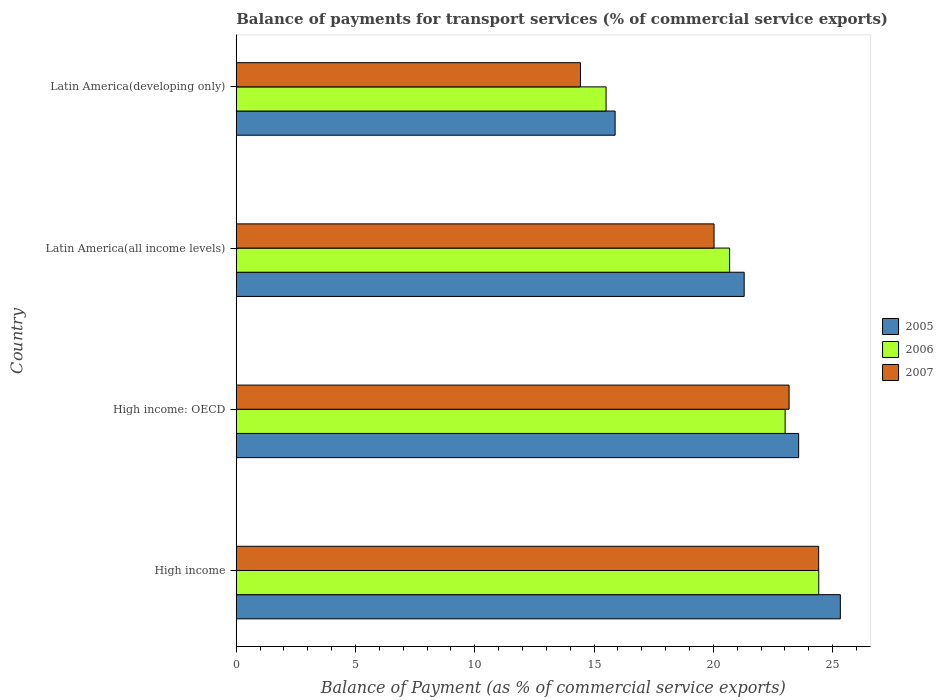How many groups of bars are there?
Provide a succinct answer. 4. Are the number of bars per tick equal to the number of legend labels?
Offer a very short reply. Yes. How many bars are there on the 3rd tick from the bottom?
Provide a succinct answer. 3. What is the label of the 1st group of bars from the top?
Ensure brevity in your answer.  Latin America(developing only). What is the balance of payments for transport services in 2005 in Latin America(developing only)?
Make the answer very short. 15.88. Across all countries, what is the maximum balance of payments for transport services in 2007?
Ensure brevity in your answer.  24.42. Across all countries, what is the minimum balance of payments for transport services in 2007?
Provide a short and direct response. 14.43. In which country was the balance of payments for transport services in 2007 minimum?
Your response must be concise. Latin America(developing only). What is the total balance of payments for transport services in 2007 in the graph?
Your response must be concise. 82.06. What is the difference between the balance of payments for transport services in 2006 in High income: OECD and that in Latin America(all income levels)?
Offer a terse response. 2.33. What is the difference between the balance of payments for transport services in 2005 in High income: OECD and the balance of payments for transport services in 2006 in Latin America(developing only)?
Offer a very short reply. 8.07. What is the average balance of payments for transport services in 2007 per country?
Make the answer very short. 20.51. What is the difference between the balance of payments for transport services in 2006 and balance of payments for transport services in 2005 in High income: OECD?
Make the answer very short. -0.57. In how many countries, is the balance of payments for transport services in 2005 greater than 4 %?
Keep it short and to the point. 4. What is the ratio of the balance of payments for transport services in 2007 in Latin America(all income levels) to that in Latin America(developing only)?
Offer a terse response. 1.39. What is the difference between the highest and the second highest balance of payments for transport services in 2006?
Provide a short and direct response. 1.41. What is the difference between the highest and the lowest balance of payments for transport services in 2005?
Give a very brief answer. 9.44. What does the 3rd bar from the top in Latin America(developing only) represents?
Your answer should be compact. 2005. Are all the bars in the graph horizontal?
Give a very brief answer. Yes. Are the values on the major ticks of X-axis written in scientific E-notation?
Make the answer very short. No. Does the graph contain any zero values?
Make the answer very short. No. Where does the legend appear in the graph?
Give a very brief answer. Center right. How many legend labels are there?
Ensure brevity in your answer.  3. What is the title of the graph?
Provide a short and direct response. Balance of payments for transport services (% of commercial service exports). What is the label or title of the X-axis?
Provide a succinct answer. Balance of Payment (as % of commercial service exports). What is the label or title of the Y-axis?
Give a very brief answer. Country. What is the Balance of Payment (as % of commercial service exports) in 2005 in High income?
Your response must be concise. 25.33. What is the Balance of Payment (as % of commercial service exports) of 2006 in High income?
Provide a succinct answer. 24.42. What is the Balance of Payment (as % of commercial service exports) of 2007 in High income?
Provide a succinct answer. 24.42. What is the Balance of Payment (as % of commercial service exports) in 2005 in High income: OECD?
Offer a terse response. 23.58. What is the Balance of Payment (as % of commercial service exports) in 2006 in High income: OECD?
Offer a very short reply. 23.01. What is the Balance of Payment (as % of commercial service exports) in 2007 in High income: OECD?
Keep it short and to the point. 23.18. What is the Balance of Payment (as % of commercial service exports) in 2005 in Latin America(all income levels)?
Keep it short and to the point. 21.29. What is the Balance of Payment (as % of commercial service exports) of 2006 in Latin America(all income levels)?
Your answer should be very brief. 20.68. What is the Balance of Payment (as % of commercial service exports) in 2007 in Latin America(all income levels)?
Provide a succinct answer. 20.03. What is the Balance of Payment (as % of commercial service exports) in 2005 in Latin America(developing only)?
Offer a very short reply. 15.88. What is the Balance of Payment (as % of commercial service exports) in 2006 in Latin America(developing only)?
Make the answer very short. 15.5. What is the Balance of Payment (as % of commercial service exports) in 2007 in Latin America(developing only)?
Your response must be concise. 14.43. Across all countries, what is the maximum Balance of Payment (as % of commercial service exports) in 2005?
Your answer should be compact. 25.33. Across all countries, what is the maximum Balance of Payment (as % of commercial service exports) in 2006?
Provide a succinct answer. 24.42. Across all countries, what is the maximum Balance of Payment (as % of commercial service exports) in 2007?
Make the answer very short. 24.42. Across all countries, what is the minimum Balance of Payment (as % of commercial service exports) of 2005?
Offer a terse response. 15.88. Across all countries, what is the minimum Balance of Payment (as % of commercial service exports) in 2006?
Keep it short and to the point. 15.5. Across all countries, what is the minimum Balance of Payment (as % of commercial service exports) in 2007?
Your answer should be compact. 14.43. What is the total Balance of Payment (as % of commercial service exports) of 2005 in the graph?
Give a very brief answer. 86.08. What is the total Balance of Payment (as % of commercial service exports) of 2006 in the graph?
Your answer should be compact. 83.62. What is the total Balance of Payment (as % of commercial service exports) of 2007 in the graph?
Provide a short and direct response. 82.06. What is the difference between the Balance of Payment (as % of commercial service exports) of 2005 in High income and that in High income: OECD?
Offer a terse response. 1.75. What is the difference between the Balance of Payment (as % of commercial service exports) in 2006 in High income and that in High income: OECD?
Your response must be concise. 1.41. What is the difference between the Balance of Payment (as % of commercial service exports) in 2007 in High income and that in High income: OECD?
Offer a terse response. 1.24. What is the difference between the Balance of Payment (as % of commercial service exports) in 2005 in High income and that in Latin America(all income levels)?
Keep it short and to the point. 4.03. What is the difference between the Balance of Payment (as % of commercial service exports) in 2006 in High income and that in Latin America(all income levels)?
Provide a short and direct response. 3.74. What is the difference between the Balance of Payment (as % of commercial service exports) of 2007 in High income and that in Latin America(all income levels)?
Provide a short and direct response. 4.38. What is the difference between the Balance of Payment (as % of commercial service exports) in 2005 in High income and that in Latin America(developing only)?
Provide a short and direct response. 9.44. What is the difference between the Balance of Payment (as % of commercial service exports) of 2006 in High income and that in Latin America(developing only)?
Make the answer very short. 8.92. What is the difference between the Balance of Payment (as % of commercial service exports) in 2007 in High income and that in Latin America(developing only)?
Provide a succinct answer. 9.99. What is the difference between the Balance of Payment (as % of commercial service exports) of 2005 in High income: OECD and that in Latin America(all income levels)?
Ensure brevity in your answer.  2.28. What is the difference between the Balance of Payment (as % of commercial service exports) in 2006 in High income: OECD and that in Latin America(all income levels)?
Offer a very short reply. 2.33. What is the difference between the Balance of Payment (as % of commercial service exports) of 2007 in High income: OECD and that in Latin America(all income levels)?
Give a very brief answer. 3.15. What is the difference between the Balance of Payment (as % of commercial service exports) in 2005 in High income: OECD and that in Latin America(developing only)?
Give a very brief answer. 7.7. What is the difference between the Balance of Payment (as % of commercial service exports) in 2006 in High income: OECD and that in Latin America(developing only)?
Make the answer very short. 7.51. What is the difference between the Balance of Payment (as % of commercial service exports) in 2007 in High income: OECD and that in Latin America(developing only)?
Offer a very short reply. 8.75. What is the difference between the Balance of Payment (as % of commercial service exports) in 2005 in Latin America(all income levels) and that in Latin America(developing only)?
Your answer should be very brief. 5.41. What is the difference between the Balance of Payment (as % of commercial service exports) of 2006 in Latin America(all income levels) and that in Latin America(developing only)?
Provide a short and direct response. 5.18. What is the difference between the Balance of Payment (as % of commercial service exports) of 2007 in Latin America(all income levels) and that in Latin America(developing only)?
Your response must be concise. 5.6. What is the difference between the Balance of Payment (as % of commercial service exports) of 2005 in High income and the Balance of Payment (as % of commercial service exports) of 2006 in High income: OECD?
Offer a very short reply. 2.31. What is the difference between the Balance of Payment (as % of commercial service exports) in 2005 in High income and the Balance of Payment (as % of commercial service exports) in 2007 in High income: OECD?
Offer a terse response. 2.15. What is the difference between the Balance of Payment (as % of commercial service exports) of 2006 in High income and the Balance of Payment (as % of commercial service exports) of 2007 in High income: OECD?
Your answer should be very brief. 1.24. What is the difference between the Balance of Payment (as % of commercial service exports) in 2005 in High income and the Balance of Payment (as % of commercial service exports) in 2006 in Latin America(all income levels)?
Your answer should be compact. 4.64. What is the difference between the Balance of Payment (as % of commercial service exports) in 2005 in High income and the Balance of Payment (as % of commercial service exports) in 2007 in Latin America(all income levels)?
Provide a short and direct response. 5.29. What is the difference between the Balance of Payment (as % of commercial service exports) in 2006 in High income and the Balance of Payment (as % of commercial service exports) in 2007 in Latin America(all income levels)?
Your answer should be compact. 4.39. What is the difference between the Balance of Payment (as % of commercial service exports) of 2005 in High income and the Balance of Payment (as % of commercial service exports) of 2006 in Latin America(developing only)?
Keep it short and to the point. 9.82. What is the difference between the Balance of Payment (as % of commercial service exports) of 2005 in High income and the Balance of Payment (as % of commercial service exports) of 2007 in Latin America(developing only)?
Give a very brief answer. 10.9. What is the difference between the Balance of Payment (as % of commercial service exports) in 2006 in High income and the Balance of Payment (as % of commercial service exports) in 2007 in Latin America(developing only)?
Your answer should be compact. 9.99. What is the difference between the Balance of Payment (as % of commercial service exports) of 2005 in High income: OECD and the Balance of Payment (as % of commercial service exports) of 2006 in Latin America(all income levels)?
Provide a short and direct response. 2.9. What is the difference between the Balance of Payment (as % of commercial service exports) of 2005 in High income: OECD and the Balance of Payment (as % of commercial service exports) of 2007 in Latin America(all income levels)?
Provide a short and direct response. 3.55. What is the difference between the Balance of Payment (as % of commercial service exports) in 2006 in High income: OECD and the Balance of Payment (as % of commercial service exports) in 2007 in Latin America(all income levels)?
Give a very brief answer. 2.98. What is the difference between the Balance of Payment (as % of commercial service exports) of 2005 in High income: OECD and the Balance of Payment (as % of commercial service exports) of 2006 in Latin America(developing only)?
Give a very brief answer. 8.07. What is the difference between the Balance of Payment (as % of commercial service exports) of 2005 in High income: OECD and the Balance of Payment (as % of commercial service exports) of 2007 in Latin America(developing only)?
Provide a short and direct response. 9.15. What is the difference between the Balance of Payment (as % of commercial service exports) in 2006 in High income: OECD and the Balance of Payment (as % of commercial service exports) in 2007 in Latin America(developing only)?
Your answer should be compact. 8.58. What is the difference between the Balance of Payment (as % of commercial service exports) of 2005 in Latin America(all income levels) and the Balance of Payment (as % of commercial service exports) of 2006 in Latin America(developing only)?
Keep it short and to the point. 5.79. What is the difference between the Balance of Payment (as % of commercial service exports) of 2005 in Latin America(all income levels) and the Balance of Payment (as % of commercial service exports) of 2007 in Latin America(developing only)?
Your answer should be compact. 6.86. What is the difference between the Balance of Payment (as % of commercial service exports) of 2006 in Latin America(all income levels) and the Balance of Payment (as % of commercial service exports) of 2007 in Latin America(developing only)?
Give a very brief answer. 6.25. What is the average Balance of Payment (as % of commercial service exports) of 2005 per country?
Offer a very short reply. 21.52. What is the average Balance of Payment (as % of commercial service exports) of 2006 per country?
Provide a short and direct response. 20.91. What is the average Balance of Payment (as % of commercial service exports) of 2007 per country?
Keep it short and to the point. 20.51. What is the difference between the Balance of Payment (as % of commercial service exports) of 2005 and Balance of Payment (as % of commercial service exports) of 2006 in High income?
Make the answer very short. 0.91. What is the difference between the Balance of Payment (as % of commercial service exports) in 2005 and Balance of Payment (as % of commercial service exports) in 2007 in High income?
Offer a terse response. 0.91. What is the difference between the Balance of Payment (as % of commercial service exports) of 2006 and Balance of Payment (as % of commercial service exports) of 2007 in High income?
Provide a succinct answer. 0. What is the difference between the Balance of Payment (as % of commercial service exports) of 2005 and Balance of Payment (as % of commercial service exports) of 2006 in High income: OECD?
Make the answer very short. 0.57. What is the difference between the Balance of Payment (as % of commercial service exports) in 2005 and Balance of Payment (as % of commercial service exports) in 2007 in High income: OECD?
Make the answer very short. 0.4. What is the difference between the Balance of Payment (as % of commercial service exports) in 2006 and Balance of Payment (as % of commercial service exports) in 2007 in High income: OECD?
Ensure brevity in your answer.  -0.17. What is the difference between the Balance of Payment (as % of commercial service exports) in 2005 and Balance of Payment (as % of commercial service exports) in 2006 in Latin America(all income levels)?
Your answer should be very brief. 0.61. What is the difference between the Balance of Payment (as % of commercial service exports) in 2005 and Balance of Payment (as % of commercial service exports) in 2007 in Latin America(all income levels)?
Keep it short and to the point. 1.26. What is the difference between the Balance of Payment (as % of commercial service exports) of 2006 and Balance of Payment (as % of commercial service exports) of 2007 in Latin America(all income levels)?
Ensure brevity in your answer.  0.65. What is the difference between the Balance of Payment (as % of commercial service exports) in 2005 and Balance of Payment (as % of commercial service exports) in 2006 in Latin America(developing only)?
Offer a terse response. 0.38. What is the difference between the Balance of Payment (as % of commercial service exports) in 2005 and Balance of Payment (as % of commercial service exports) in 2007 in Latin America(developing only)?
Provide a succinct answer. 1.45. What is the difference between the Balance of Payment (as % of commercial service exports) of 2006 and Balance of Payment (as % of commercial service exports) of 2007 in Latin America(developing only)?
Give a very brief answer. 1.07. What is the ratio of the Balance of Payment (as % of commercial service exports) of 2005 in High income to that in High income: OECD?
Offer a terse response. 1.07. What is the ratio of the Balance of Payment (as % of commercial service exports) in 2006 in High income to that in High income: OECD?
Provide a succinct answer. 1.06. What is the ratio of the Balance of Payment (as % of commercial service exports) of 2007 in High income to that in High income: OECD?
Make the answer very short. 1.05. What is the ratio of the Balance of Payment (as % of commercial service exports) of 2005 in High income to that in Latin America(all income levels)?
Your answer should be very brief. 1.19. What is the ratio of the Balance of Payment (as % of commercial service exports) of 2006 in High income to that in Latin America(all income levels)?
Provide a succinct answer. 1.18. What is the ratio of the Balance of Payment (as % of commercial service exports) in 2007 in High income to that in Latin America(all income levels)?
Offer a very short reply. 1.22. What is the ratio of the Balance of Payment (as % of commercial service exports) of 2005 in High income to that in Latin America(developing only)?
Ensure brevity in your answer.  1.59. What is the ratio of the Balance of Payment (as % of commercial service exports) in 2006 in High income to that in Latin America(developing only)?
Give a very brief answer. 1.57. What is the ratio of the Balance of Payment (as % of commercial service exports) in 2007 in High income to that in Latin America(developing only)?
Offer a very short reply. 1.69. What is the ratio of the Balance of Payment (as % of commercial service exports) of 2005 in High income: OECD to that in Latin America(all income levels)?
Keep it short and to the point. 1.11. What is the ratio of the Balance of Payment (as % of commercial service exports) of 2006 in High income: OECD to that in Latin America(all income levels)?
Make the answer very short. 1.11. What is the ratio of the Balance of Payment (as % of commercial service exports) of 2007 in High income: OECD to that in Latin America(all income levels)?
Offer a terse response. 1.16. What is the ratio of the Balance of Payment (as % of commercial service exports) of 2005 in High income: OECD to that in Latin America(developing only)?
Offer a terse response. 1.48. What is the ratio of the Balance of Payment (as % of commercial service exports) of 2006 in High income: OECD to that in Latin America(developing only)?
Ensure brevity in your answer.  1.48. What is the ratio of the Balance of Payment (as % of commercial service exports) of 2007 in High income: OECD to that in Latin America(developing only)?
Make the answer very short. 1.61. What is the ratio of the Balance of Payment (as % of commercial service exports) of 2005 in Latin America(all income levels) to that in Latin America(developing only)?
Your answer should be compact. 1.34. What is the ratio of the Balance of Payment (as % of commercial service exports) of 2006 in Latin America(all income levels) to that in Latin America(developing only)?
Ensure brevity in your answer.  1.33. What is the ratio of the Balance of Payment (as % of commercial service exports) in 2007 in Latin America(all income levels) to that in Latin America(developing only)?
Your answer should be compact. 1.39. What is the difference between the highest and the second highest Balance of Payment (as % of commercial service exports) in 2005?
Offer a terse response. 1.75. What is the difference between the highest and the second highest Balance of Payment (as % of commercial service exports) of 2006?
Your answer should be very brief. 1.41. What is the difference between the highest and the second highest Balance of Payment (as % of commercial service exports) in 2007?
Ensure brevity in your answer.  1.24. What is the difference between the highest and the lowest Balance of Payment (as % of commercial service exports) in 2005?
Your answer should be compact. 9.44. What is the difference between the highest and the lowest Balance of Payment (as % of commercial service exports) in 2006?
Make the answer very short. 8.92. What is the difference between the highest and the lowest Balance of Payment (as % of commercial service exports) of 2007?
Offer a terse response. 9.99. 